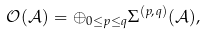Convert formula to latex. <formula><loc_0><loc_0><loc_500><loc_500>{ \mathcal { O ( A ) } } = \oplus _ { 0 \leq p \leq q } \Sigma ^ { ( p , q ) } ( \mathcal { A } ) ,</formula> 